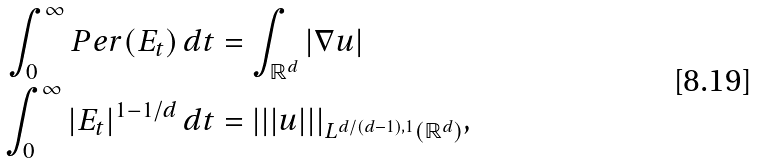<formula> <loc_0><loc_0><loc_500><loc_500>\int _ { 0 } ^ { \infty } P e r ( E _ { t } ) \, d t & = \int _ { \mathbb { R } ^ { d } } | \nabla u | \\ \int _ { 0 } ^ { \infty } | E _ { t } | ^ { 1 - 1 / d } \, d t & = | | | u | | | _ { L ^ { d / ( d - 1 ) , 1 } ( \mathbb { R } ^ { d } ) } ,</formula> 